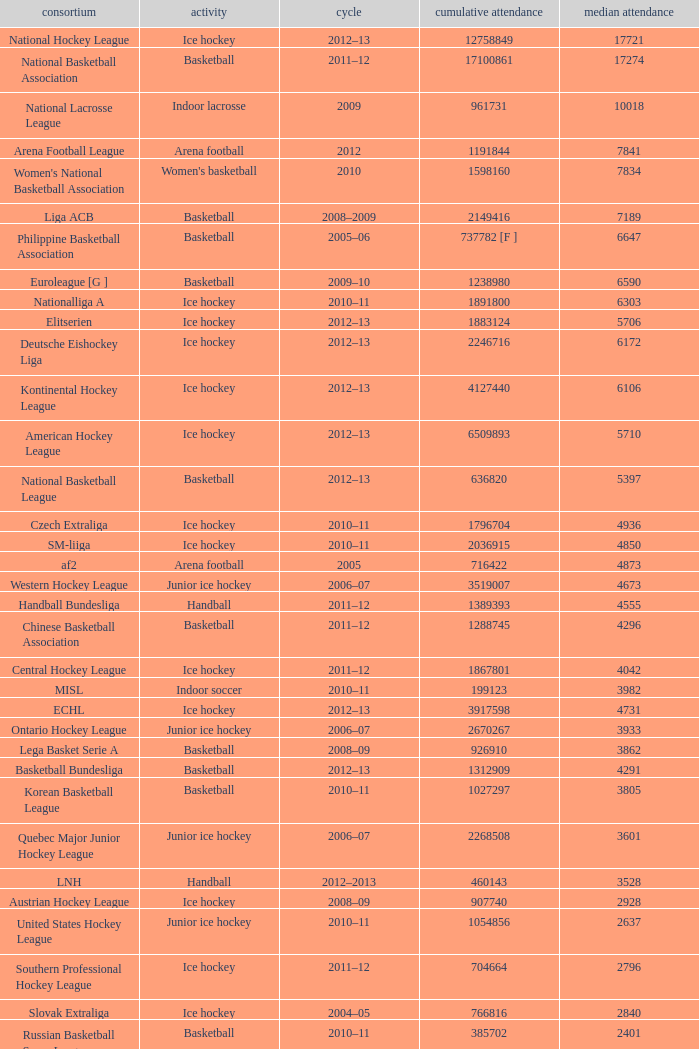Would you mind parsing the complete table? {'header': ['consortium', 'activity', 'cycle', 'cumulative attendance', 'median attendance'], 'rows': [['National Hockey League', 'Ice hockey', '2012–13', '12758849', '17721'], ['National Basketball Association', 'Basketball', '2011–12', '17100861', '17274'], ['National Lacrosse League', 'Indoor lacrosse', '2009', '961731', '10018'], ['Arena Football League', 'Arena football', '2012', '1191844', '7841'], ["Women's National Basketball Association", "Women's basketball", '2010', '1598160', '7834'], ['Liga ACB', 'Basketball', '2008–2009', '2149416', '7189'], ['Philippine Basketball Association', 'Basketball', '2005–06', '737782 [F ]', '6647'], ['Euroleague [G ]', 'Basketball', '2009–10', '1238980', '6590'], ['Nationalliga A', 'Ice hockey', '2010–11', '1891800', '6303'], ['Elitserien', 'Ice hockey', '2012–13', '1883124', '5706'], ['Deutsche Eishockey Liga', 'Ice hockey', '2012–13', '2246716', '6172'], ['Kontinental Hockey League', 'Ice hockey', '2012–13', '4127440', '6106'], ['American Hockey League', 'Ice hockey', '2012–13', '6509893', '5710'], ['National Basketball League', 'Basketball', '2012–13', '636820', '5397'], ['Czech Extraliga', 'Ice hockey', '2010–11', '1796704', '4936'], ['SM-liiga', 'Ice hockey', '2010–11', '2036915', '4850'], ['af2', 'Arena football', '2005', '716422', '4873'], ['Western Hockey League', 'Junior ice hockey', '2006–07', '3519007', '4673'], ['Handball Bundesliga', 'Handball', '2011–12', '1389393', '4555'], ['Chinese Basketball Association', 'Basketball', '2011–12', '1288745', '4296'], ['Central Hockey League', 'Ice hockey', '2011–12', '1867801', '4042'], ['MISL', 'Indoor soccer', '2010–11', '199123', '3982'], ['ECHL', 'Ice hockey', '2012–13', '3917598', '4731'], ['Ontario Hockey League', 'Junior ice hockey', '2006–07', '2670267', '3933'], ['Lega Basket Serie A', 'Basketball', '2008–09', '926910', '3862'], ['Basketball Bundesliga', 'Basketball', '2012–13', '1312909', '4291'], ['Korean Basketball League', 'Basketball', '2010–11', '1027297', '3805'], ['Quebec Major Junior Hockey League', 'Junior ice hockey', '2006–07', '2268508', '3601'], ['LNH', 'Handball', '2012–2013', '460143', '3528'], ['Austrian Hockey League', 'Ice hockey', '2008–09', '907740', '2928'], ['United States Hockey League', 'Junior ice hockey', '2010–11', '1054856', '2637'], ['Southern Professional Hockey League', 'Ice hockey', '2011–12', '704664', '2796'], ['Slovak Extraliga', 'Ice hockey', '2004–05', '766816', '2840'], ['Russian Basketball Super League', 'Basketball', '2010–11', '385702', '2401'], ['Lega Pallavolo Serie A', 'Volleyball', '2005–06', '469799', '2512'], ['HockeyAllsvenskan', 'Ice hockey', '2012–13', '1174766', '3227'], ['Elite Ice Hockey League', 'Ice Hockey', '2009–10', '743040', '2322'], ['Oddset Ligaen', 'Ice hockey', '2007–08', '407972', '1534'], ['UPC Ligaen', 'Ice hockey', '2005–06', '329768', '1335'], ['North American Hockey League', 'Junior ice hockey', '2010–11', '957323', '1269'], ['Pro A Volleyball', 'Volleyball', '2005–06', '213678', '1174'], ['Italian Rink Hockey League', 'Rink hockey', '2007–08', '115000', '632'], ['Minor Hockey League', 'Ice Hockey', '2012–13', '479003', '467'], ['Major Hockey League', 'Ice Hockey', '2012–13', '1356319', '1932'], ['VTB United League', 'Basketball', '2012–13', '572747', '2627'], ['Norwegian Premier League', "Women's handball", '2005–06', '58958', '447'], ['Polska Liga Koszykówki', 'Basketball', '2011–12', '535559', '1940']]} What was the highest average attendance in the 2009 season? 10018.0. 